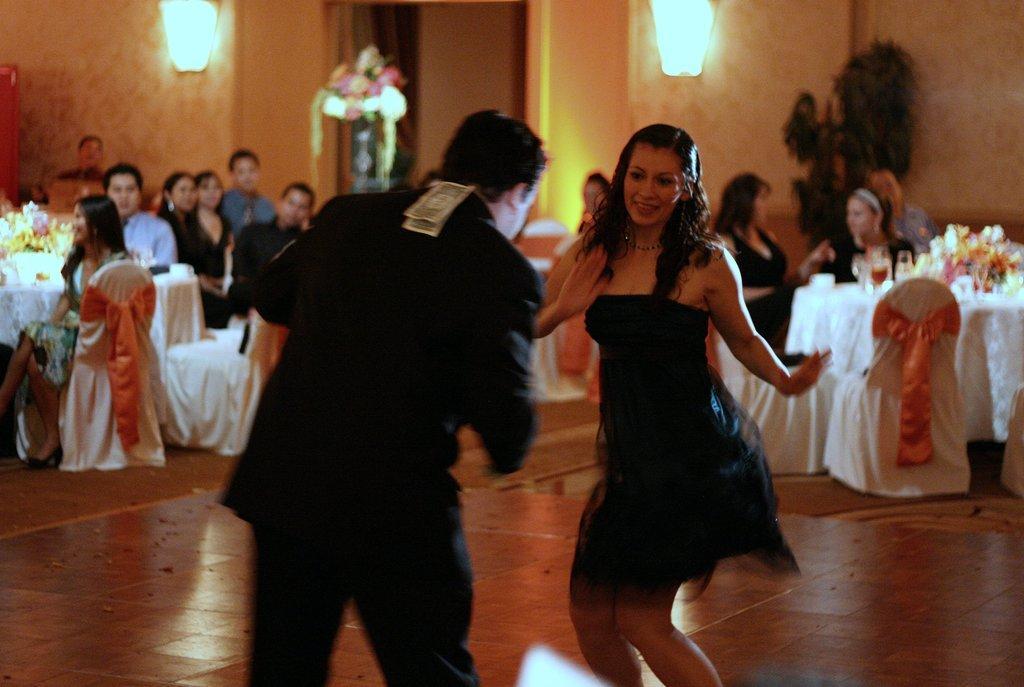In one or two sentences, can you explain what this image depicts? In this picture there are two persons dancing. At the back there are group of people sitting and there are flower vases and glasses on the tables and tables are covered with white color clothes and there are chairs and there is a plant and there are lights on the wall and there is a flower vase. At the bottom there is a floor. 